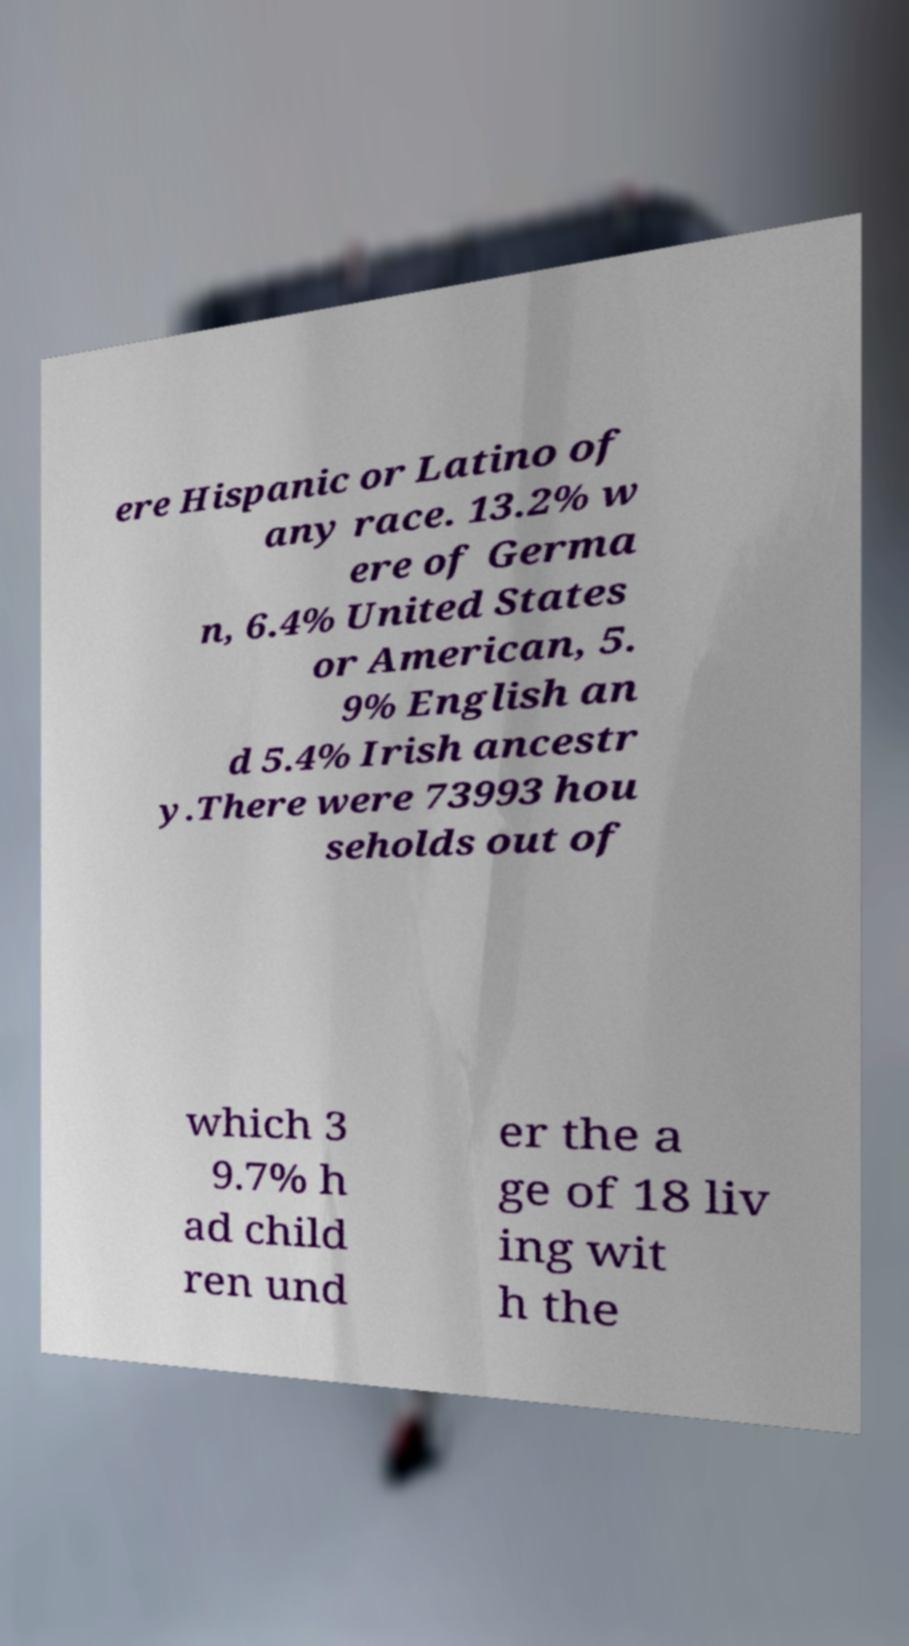For documentation purposes, I need the text within this image transcribed. Could you provide that? ere Hispanic or Latino of any race. 13.2% w ere of Germa n, 6.4% United States or American, 5. 9% English an d 5.4% Irish ancestr y.There were 73993 hou seholds out of which 3 9.7% h ad child ren und er the a ge of 18 liv ing wit h the 